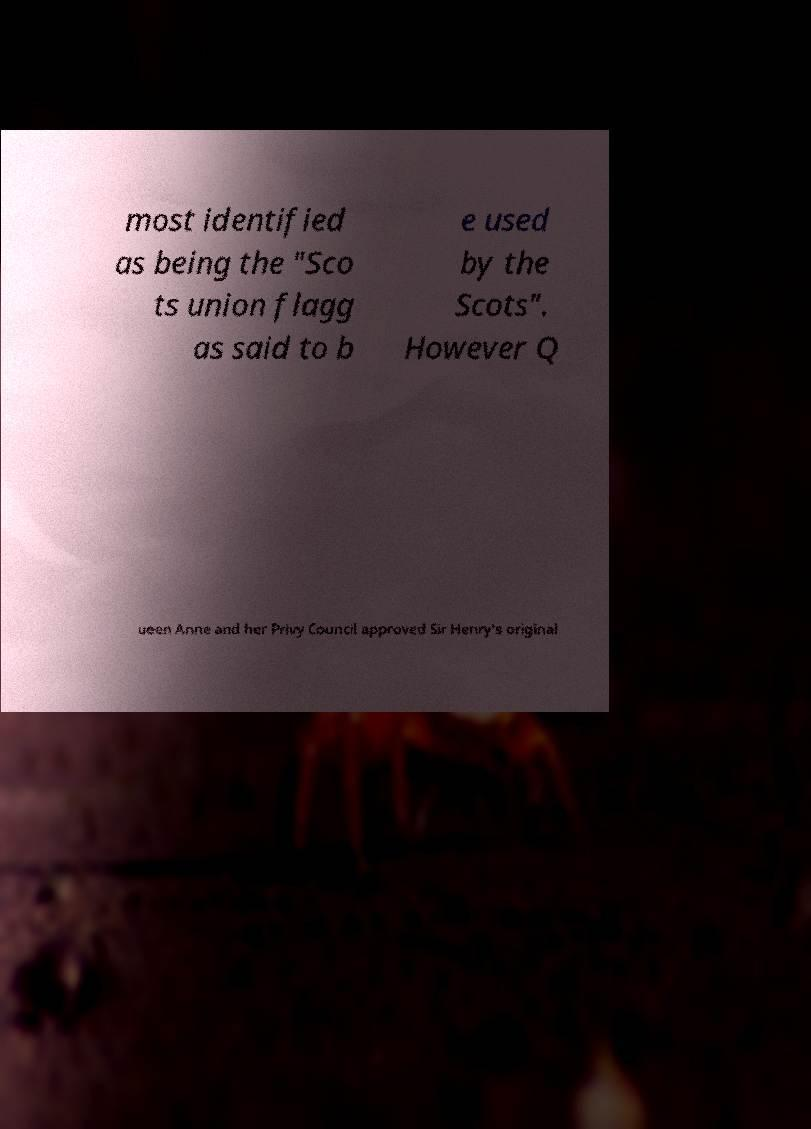I need the written content from this picture converted into text. Can you do that? most identified as being the "Sco ts union flagg as said to b e used by the Scots". However Q ueen Anne and her Privy Council approved Sir Henry's original 